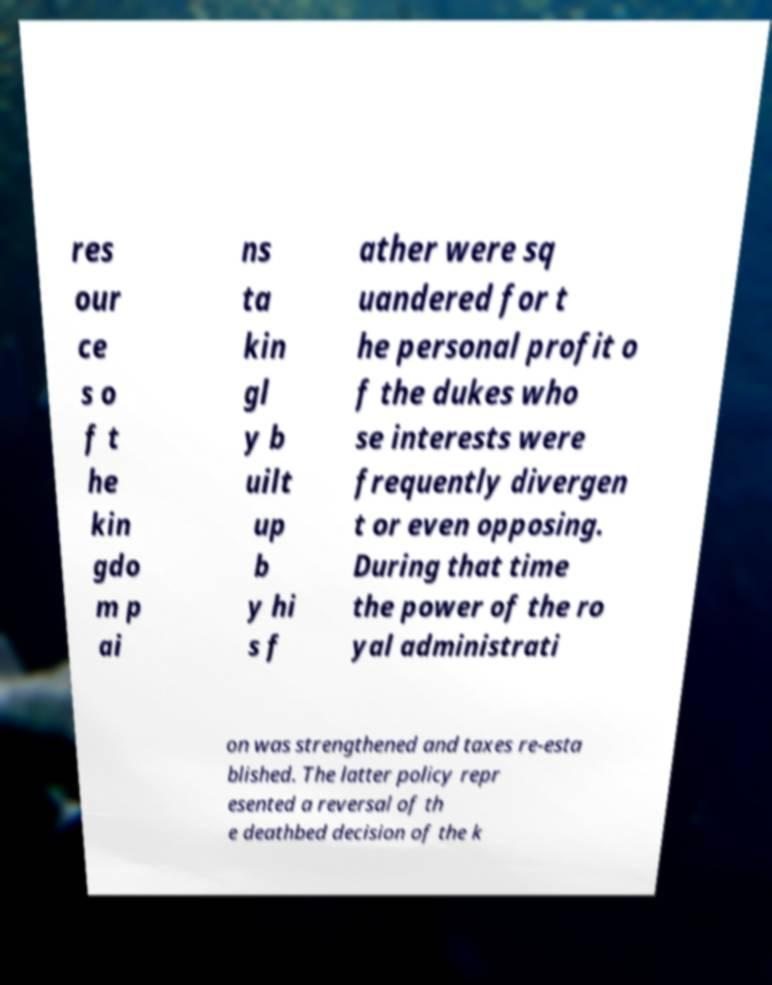There's text embedded in this image that I need extracted. Can you transcribe it verbatim? res our ce s o f t he kin gdo m p ai ns ta kin gl y b uilt up b y hi s f ather were sq uandered for t he personal profit o f the dukes who se interests were frequently divergen t or even opposing. During that time the power of the ro yal administrati on was strengthened and taxes re-esta blished. The latter policy repr esented a reversal of th e deathbed decision of the k 